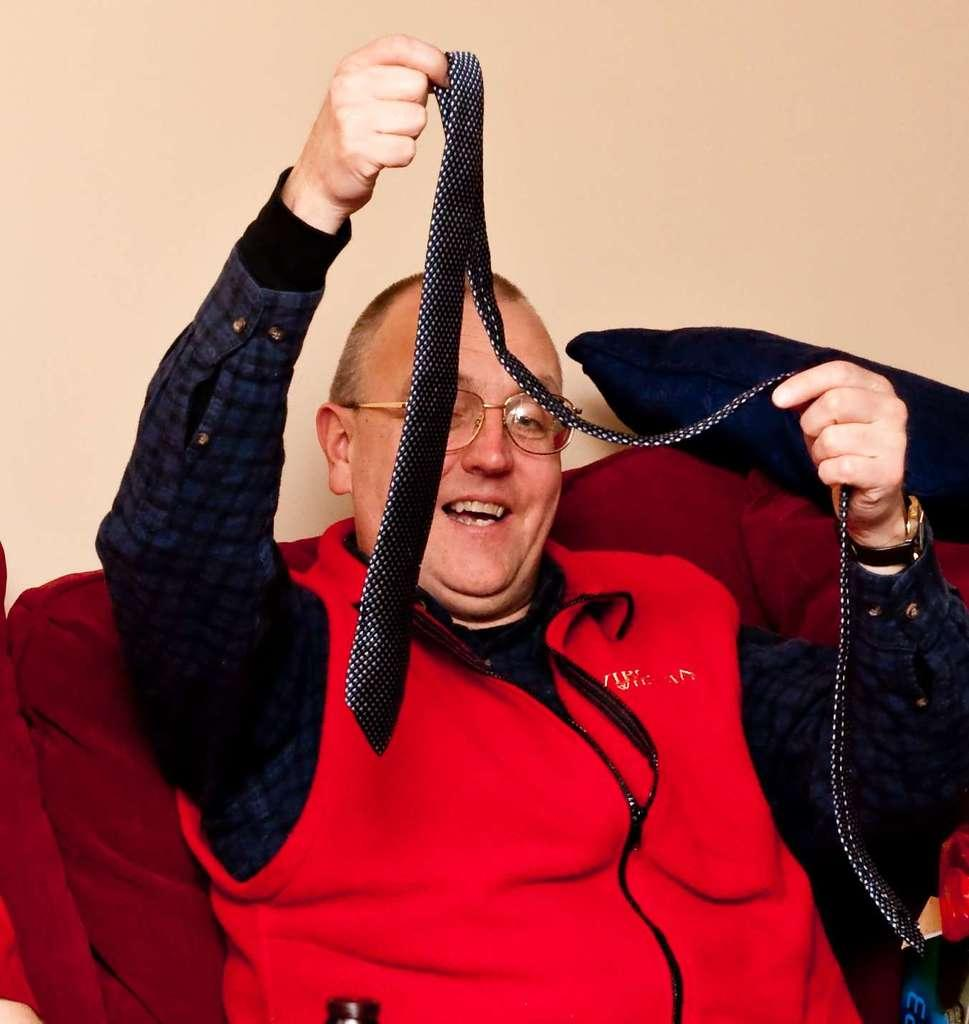What is the person in the image wearing? The person is wearing a red jacket. What is the person doing in the image? The person is sitting on a sofa. What is the person holding in their hands? The person is holding an object in their hands. What can be seen in the right corner of the image? There is a pillow in the right corner of the image. What type of straw is the person using to drink from the object they are holding? There is no straw present in the image, and the object being held is not specified. --- Facts: 1. There is a car in the image. 2. The car is parked on the street. 3. There are trees in the background of the image. 4. The sky is visible in the image. 5. The car has a blue color. Absurd Topics: parrot, sand, umbrella Conversation: What is the main subject of the image? The main subject of the image is a car. Where is the car located in the image? The car is parked on the street. What can be seen in the background of the image? There are trees in the background of the image. What is visible in the image besides the car and trees? The sky is visible in the image. What color is the car in the image? The car has a blue color. Reasoning: Let's think step by step in order to produce the conversation. We start by identifying the main subject in the image, which is the car. Then, we describe the car's location, the background, and the visible sky. Finally, we mention a detail about the car itself, which is its blue color. Absurd Question/Answer: Can you tell me how many parrots are sitting on the car's roof in the image? There are no parrots present in the image; it only features a car parked on the street with trees and the sky visible in the background. 